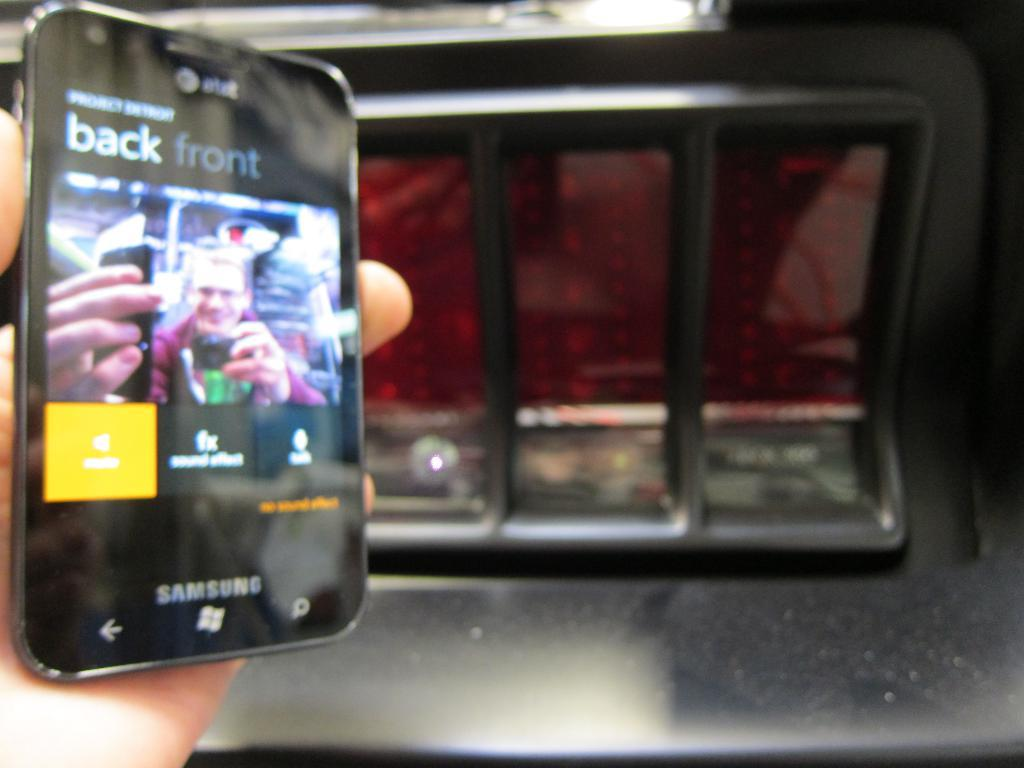<image>
Relay a brief, clear account of the picture shown. A samsung smart device that says back front on it. 